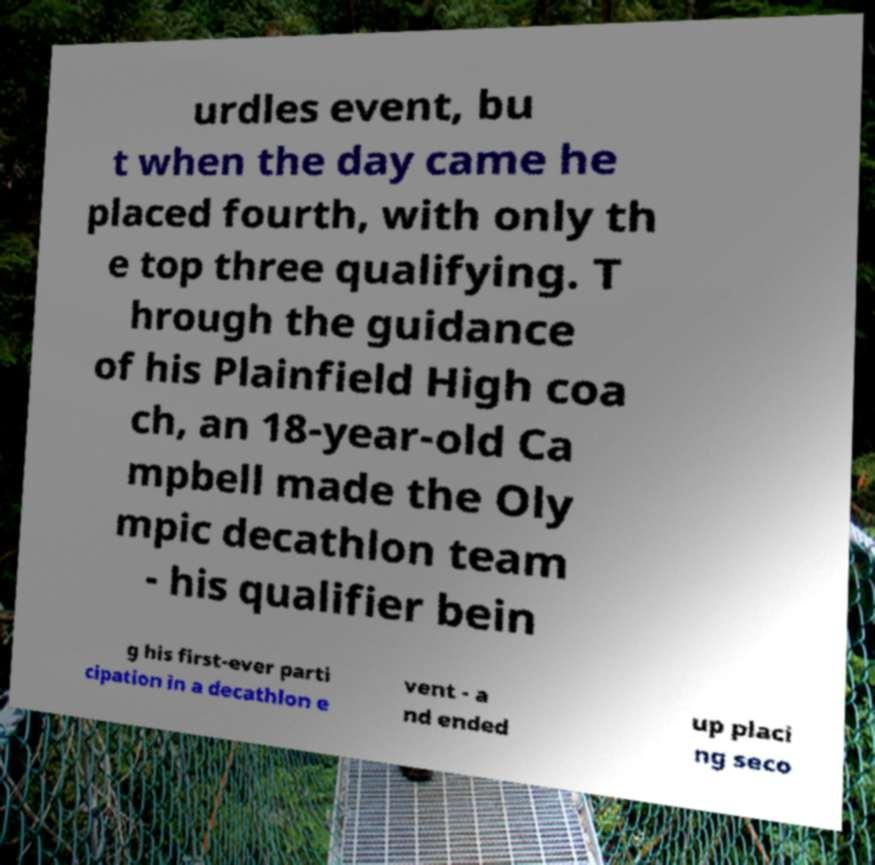For documentation purposes, I need the text within this image transcribed. Could you provide that? urdles event, bu t when the day came he placed fourth, with only th e top three qualifying. T hrough the guidance of his Plainfield High coa ch, an 18-year-old Ca mpbell made the Oly mpic decathlon team - his qualifier bein g his first-ever parti cipation in a decathlon e vent - a nd ended up placi ng seco 